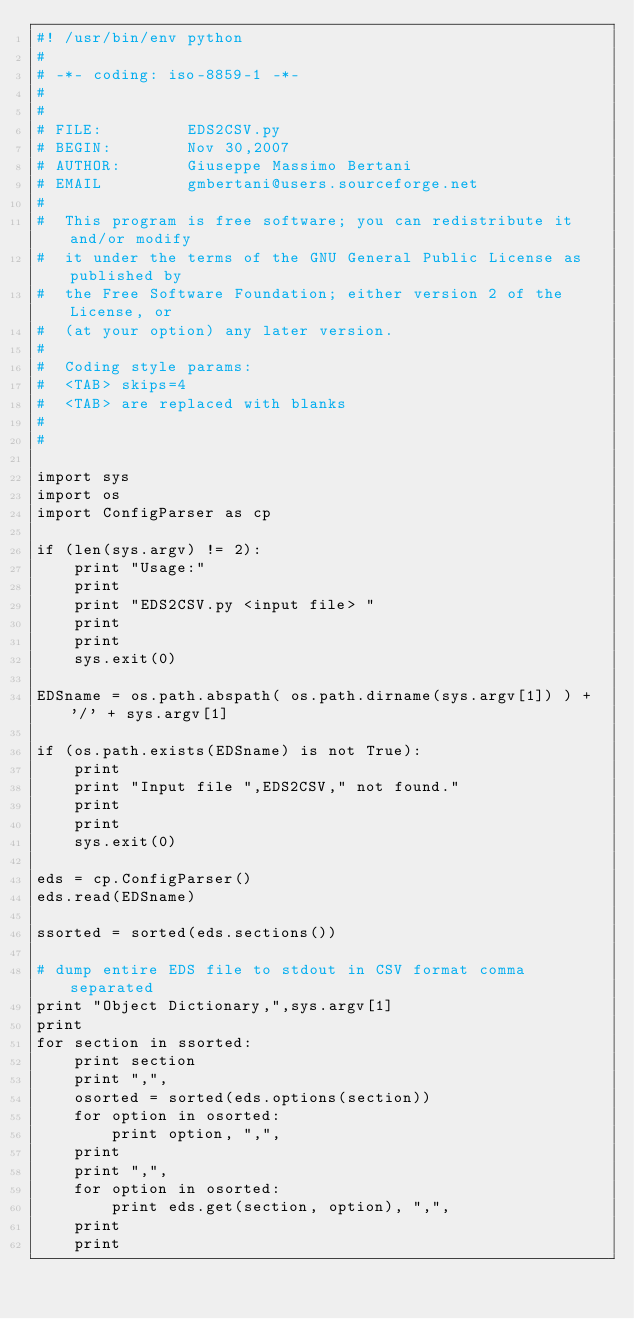<code> <loc_0><loc_0><loc_500><loc_500><_Python_>#! /usr/bin/env python
#
# -*- coding: iso-8859-1 -*-
#
#
# FILE:         EDS2CSV.py
# BEGIN:        Nov 30,2007
# AUTHOR:       Giuseppe Massimo Bertani
# EMAIL         gmbertani@users.sourceforge.net
#
#  This program is free software; you can redistribute it and/or modify
#  it under the terms of the GNU General Public License as published by
#  the Free Software Foundation; either version 2 of the License, or
#  (at your option) any later version.
#
#  Coding style params:
#  <TAB> skips=4
#  <TAB> are replaced with blanks
#
#

import sys
import os
import ConfigParser as cp

if (len(sys.argv) != 2):
    print "Usage:"
    print 
    print "EDS2CSV.py <input file> "
    print
    print
    sys.exit(0)

EDSname = os.path.abspath( os.path.dirname(sys.argv[1]) ) + '/' + sys.argv[1] 

if (os.path.exists(EDSname) is not True):
    print 
    print "Input file ",EDS2CSV," not found."
    print
    print
    sys.exit(0)

eds = cp.ConfigParser()
eds.read(EDSname)
    
ssorted = sorted(eds.sections())

# dump entire EDS file to stdout in CSV format comma separated
print "Object Dictionary,",sys.argv[1]
print
for section in ssorted:
    print section
    print ",", 
    osorted = sorted(eds.options(section))
    for option in osorted:
        print option, ",", 
    print
    print ",", 
    for option in osorted:
        print eds.get(section, option), ",",    
    print
    print

</code> 